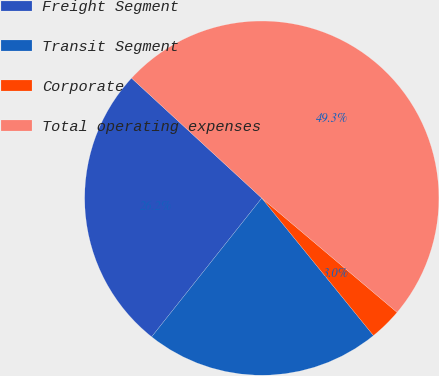<chart> <loc_0><loc_0><loc_500><loc_500><pie_chart><fcel>Freight Segment<fcel>Transit Segment<fcel>Corporate<fcel>Total operating expenses<nl><fcel>26.17%<fcel>21.54%<fcel>2.98%<fcel>49.31%<nl></chart> 